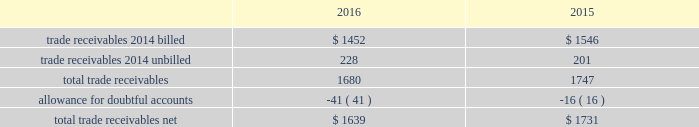Fidelity national information services , inc .
And subsidiaries notes to consolidated financial statements - ( continued ) contingent consideration liabilities recorded in connection with business acquisitions must also be adjusted for changes in fair value until settled .
See note 3 for discussion of the capital markets company bvba ( "capco" ) contingent consideration liability .
( d ) derivative financial instruments the company accounts for derivative financial instruments in accordance with financial accounting standards board accounting standards codification ( 201cfasb asc 201d ) topic 815 , derivatives and hedging .
During 2016 , 2015 and 2014 , the company engaged in g hedging activities relating to its variable rate debt through the use of interest rate swaps .
The company designates these interest rate swaps as cash flow hedges .
The estimated fair values of the cash flow hedges are determined using level 2 type measurements .
Thh ey are recorded as an asset or liability of the company and are included in the accompanying consolidated balance sheets in prepaid expenses and other current assets , other non-current assets , accounts payable and accrued liabilities or other long-term liabilities , as appropriate , and as a component of accumulated other comprehensive earnings , net of deferred taxes .
A portion of the amount included in accumulated other comprehensive earnings is recorded in interest expense as a yield adjustment as interest payments are made on then company 2019s term and revolving loans ( note 10 ) .
The company 2019s existing cash flow hedge is highly effective and there was no impact on 2016 earnings due to hedge ineffectiveness .
It is our policy to execute such instruments with credit-worthy banks and not to enter into derivative financial instruments for speculative purposes .
As of december 31 , 2016 , we believe that our interest rate swap counterparty will be able to fulfill its obligations under our agreement .
The company's foreign exchange risk management policy permits the use of derivative instruments , such as forward contracts and options , to reduce volatility in the company's results of operations and/or cash flows resulting from foreign exchange rate fluctuations .
During 2016 and 2015 , the company entered into foreign currency forward exchange contracts to hedge foreign currency exposure to intercompany loans .
As of december 31 , 2016 and 2015 , the notional amount of these derivatives was approximately $ 143 million and aa $ 81 million , respectively , and the fair value was nominal .
These derivatives have not been designated as hedges for accounting purposes .
We also use currency forward contracts to manage our exposure to fluctuations in costs caused by variations in indian rupee ( "inr" ) ii exchange rates .
As of december 31 , 2016 , the notional amount of these derivatives was approximately $ 7 million and the fair value was l less than $ 1 million , which is included in prepaid expenses and other current assets in the consolidated balance sheets .
These inr forward contracts are designated as cash flow hedges .
The fair value of these currency forward contracts is determined using currency uu exchange market rates , obtained from reliable , independent , third party banks , at the balance sheet date .
The fair value of forward rr contracts is subject to changes in currency exchange rates .
The company has no ineffectiveness related to its use of currency forward ff contracts in connection with inr cash flow hedges .
In september 2015 , the company entered into treasury lock hedges with a total notional amount of $ 1.0 billion , reducing the risk of changes in the benchmark index component of the 10-year treasury yield .
The company def signated these derivatives as cash flow hedges .
On october 13 , 2015 , in conjunction with the pricing of the $ 4.5 billion senior notes , the companyr terminated these treasury lock contracts for a cash settlement payment of $ 16 million , which was recorded as a component of other comprehensive earnings and will be reclassified as an adjustment to interest expense over the ten years during which the related interest payments that were hedged will be recognized in income .
( e ) trade receivables a summary of trade receivables , net , as of december 31 , 2016 and 2015 is as follows ( in millions ) : .

What is the percentage change in total trade net receivables? 
Computations: ((1639 - 1731) / 1731)
Answer: -0.05315. 